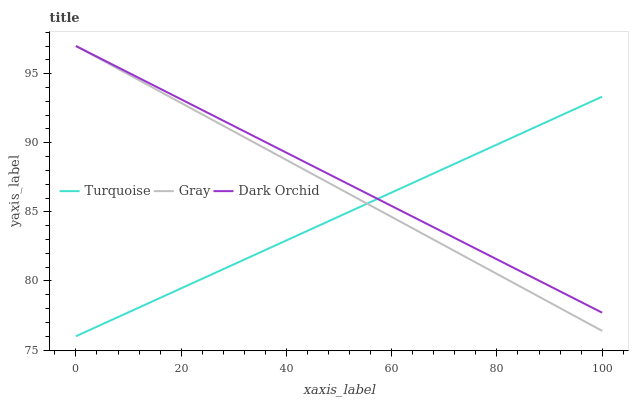Does Dark Orchid have the minimum area under the curve?
Answer yes or no. No. Does Turquoise have the maximum area under the curve?
Answer yes or no. No. Is Dark Orchid the smoothest?
Answer yes or no. No. Is Dark Orchid the roughest?
Answer yes or no. No. Does Dark Orchid have the lowest value?
Answer yes or no. No. Does Turquoise have the highest value?
Answer yes or no. No. 